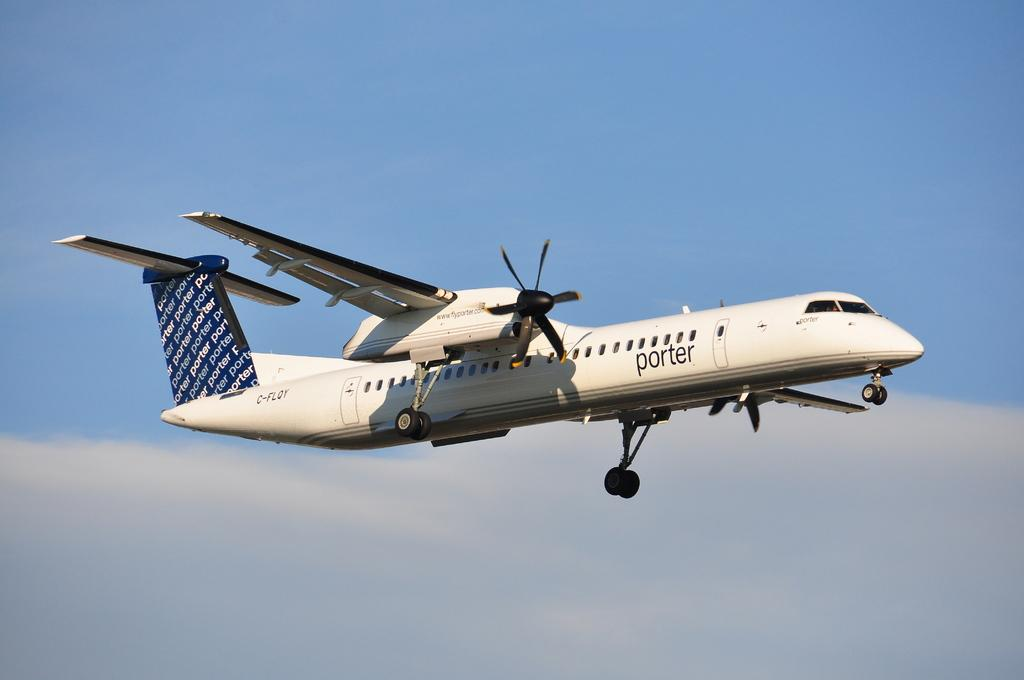What is the main subject of the image? The main subject of the image is a plane. What is the plane doing in the image? The plane is flying in the air. What can be seen in the background of the image? The sky and clouds are visible in the background of the image. What part of the plane is visible at the bottom of the image? The plane's wheels are visible at the bottom of the plane. What type of connection can be seen between the bushes and the cracker in the image? There are no bushes or crackers present in the image, so there is no connection between them. 